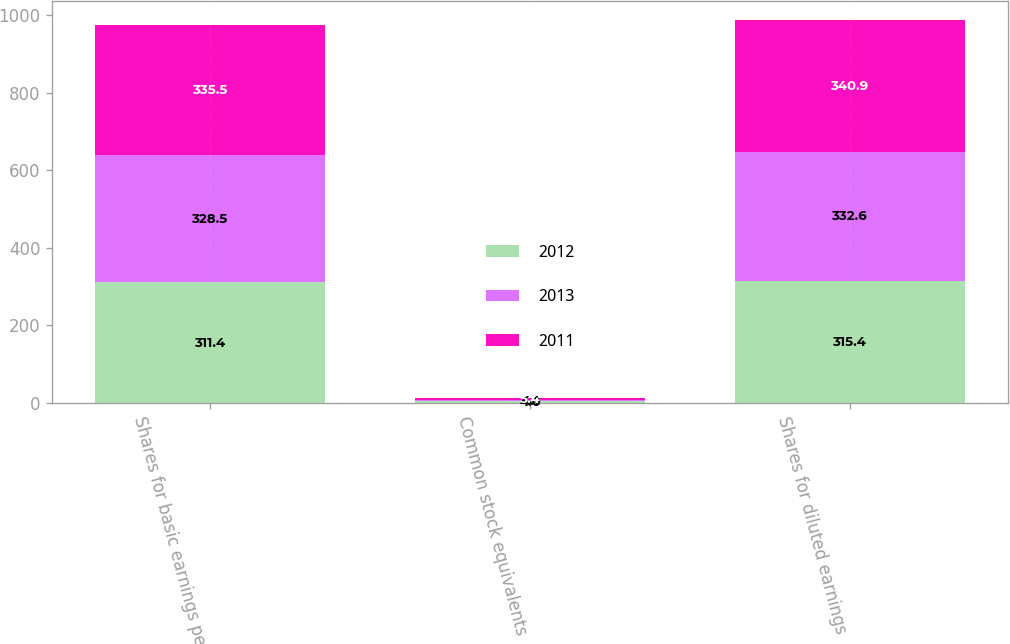<chart> <loc_0><loc_0><loc_500><loc_500><stacked_bar_chart><ecel><fcel>Shares for basic earnings per<fcel>Common stock equivalents<fcel>Shares for diluted earnings<nl><fcel>2012<fcel>311.4<fcel>4<fcel>315.4<nl><fcel>2013<fcel>328.5<fcel>4.1<fcel>332.6<nl><fcel>2011<fcel>335.5<fcel>5.4<fcel>340.9<nl></chart> 